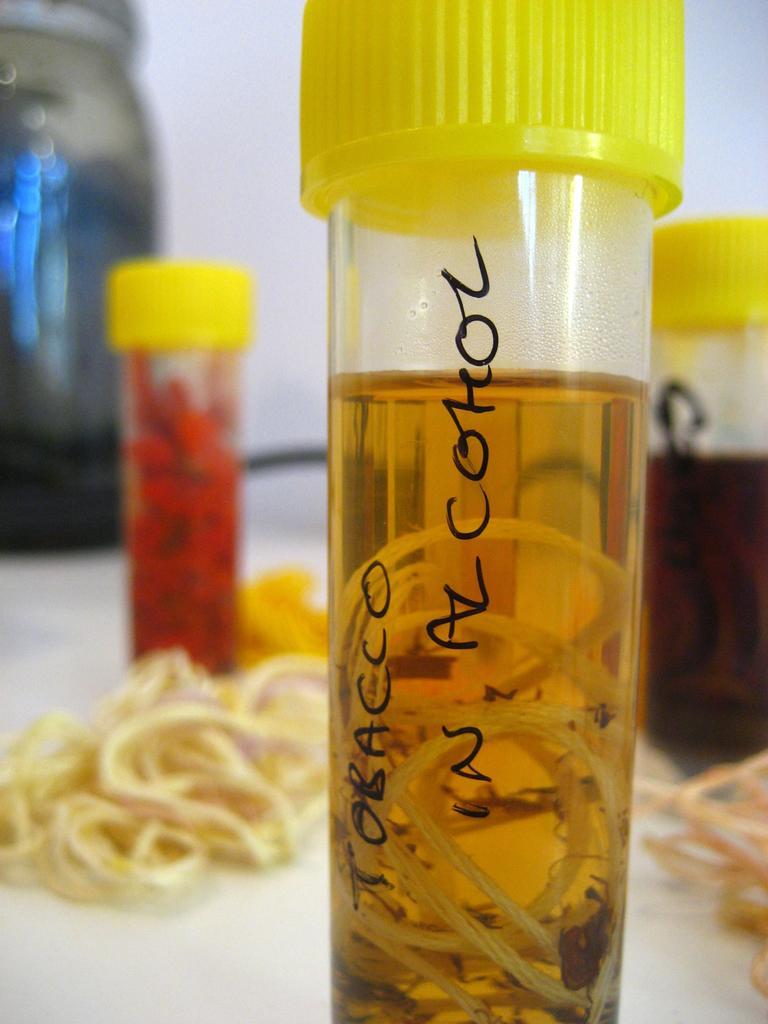In one or two sentences, can you explain what this image depicts? This picture shows small sample bottles on the table and we see some tobacco 